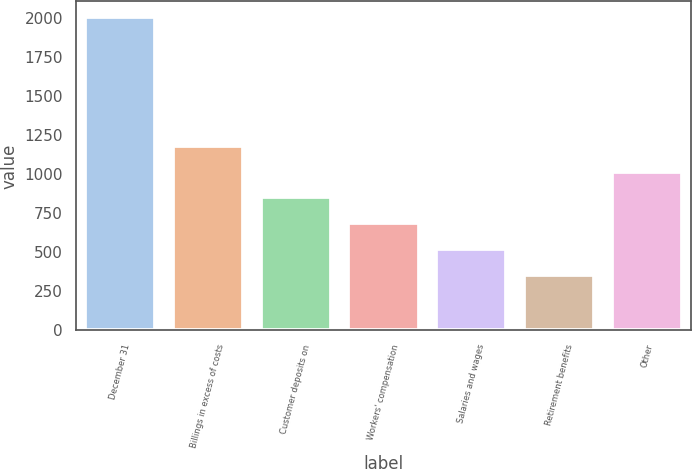Convert chart. <chart><loc_0><loc_0><loc_500><loc_500><bar_chart><fcel>December 31<fcel>Billings in excess of costs<fcel>Customer deposits on<fcel>Workers' compensation<fcel>Salaries and wages<fcel>Retirement benefits<fcel>Other<nl><fcel>2004<fcel>1179.5<fcel>849.7<fcel>684.8<fcel>519.9<fcel>355<fcel>1014.6<nl></chart> 